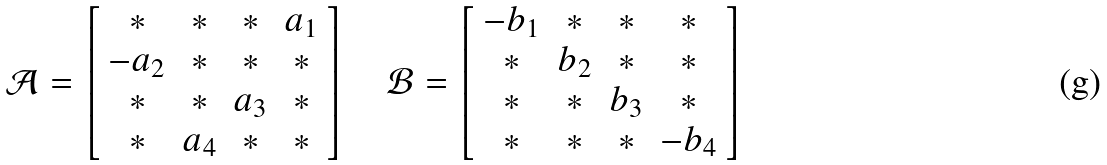Convert formula to latex. <formula><loc_0><loc_0><loc_500><loc_500>\mathcal { A } = \left [ \begin{array} { c c c c } * & * & * & a _ { 1 } \\ - a _ { 2 } & * & * & * \\ * & * & a _ { 3 } & * \\ * & a _ { 4 } & * & * \end{array} \right ] \quad \mathcal { B } = \left [ \begin{array} { c c c c } - b _ { 1 } & * & * & * \\ * & b _ { 2 } & * & * \\ * & * & b _ { 3 } & * \\ * & * & * & - b _ { 4 } \end{array} \right ]</formula> 